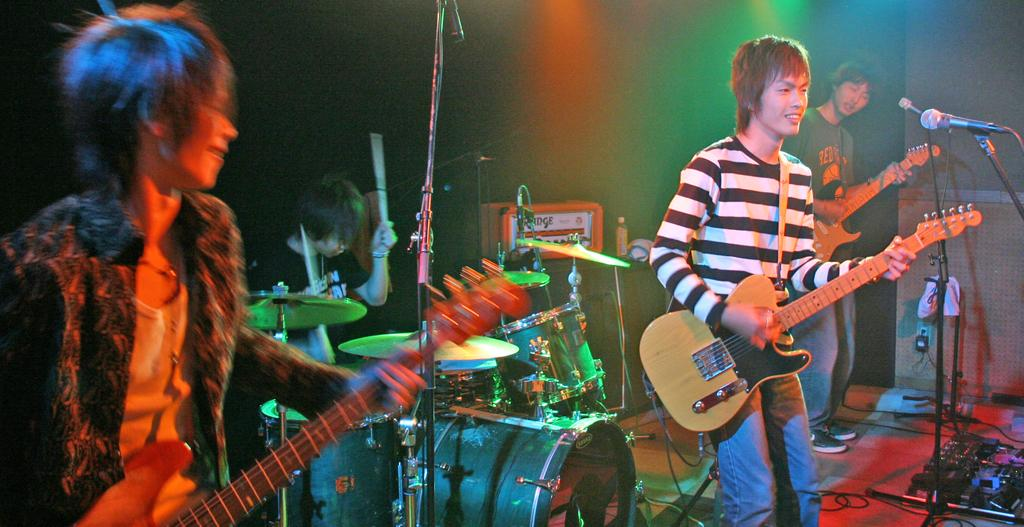How many men are in the image? There are four men in the image. What are the men doing in the image? Three of the men are standing and holding guitars, one of them is playing the guitar, and one man is sitting and playing the drums. What is in front of the man playing the guitar? There is a microphone in front of the man playing the guitar. What type of van can be seen in the background of the image? There is no van present in the image. What book is the man reading in the image? There is no man reading a book in the image; the men are playing musical instruments. 